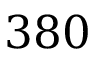Convert formula to latex. <formula><loc_0><loc_0><loc_500><loc_500>3 8 0</formula> 